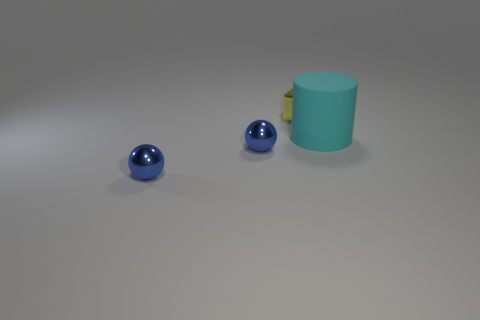Are there an equal number of big cyan things in front of the small metallic cube and big cyan matte objects?
Provide a succinct answer. Yes. Do the yellow thing and the thing that is to the right of the tiny metal cube have the same size?
Give a very brief answer. No. What number of other objects are the same size as the cylinder?
Your answer should be compact. 0. Is there any other thing that has the same size as the rubber cylinder?
Your answer should be compact. No. How many other objects are there of the same shape as the yellow thing?
Ensure brevity in your answer.  0. Are there any brown matte objects?
Give a very brief answer. No. Is there anything else that is the same material as the large cyan thing?
Offer a very short reply. No. Are there any other large cylinders that have the same material as the cylinder?
Your answer should be compact. No. What number of yellow objects are the same size as the cyan cylinder?
Provide a succinct answer. 0. How many things are large rubber things in front of the tiny block or big rubber cylinders that are in front of the tiny yellow object?
Your response must be concise. 1. 